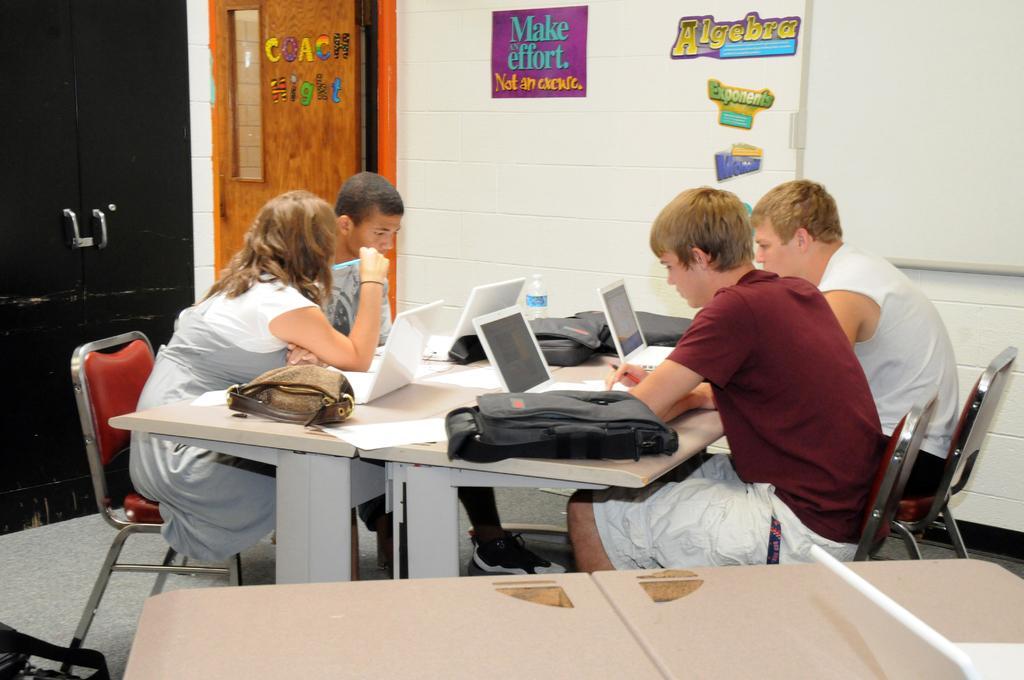Could you give a brief overview of what you see in this image? In this image, group of people are sat on the red chair. In the middle, there is a table, few items are placed on it. At the bottom, there is an another table. At the background, there is a few stickers on the wall, orange color door. Left side, there is a black color door. 